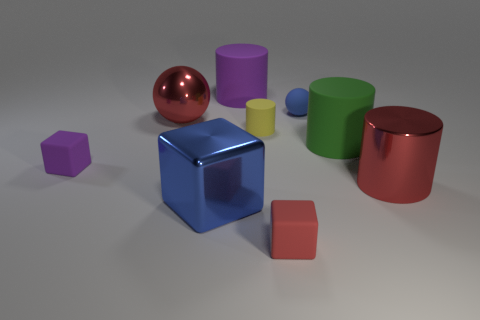Subtract all spheres. How many objects are left? 7 Subtract all big shiny blocks. Subtract all tiny brown metallic balls. How many objects are left? 8 Add 2 tiny red rubber things. How many tiny red rubber things are left? 3 Add 3 purple rubber objects. How many purple rubber objects exist? 5 Subtract 1 red cubes. How many objects are left? 8 